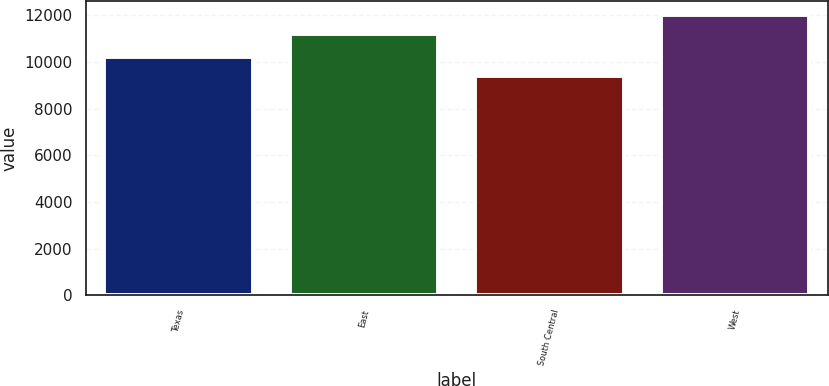Convert chart to OTSL. <chart><loc_0><loc_0><loc_500><loc_500><bar_chart><fcel>Texas<fcel>East<fcel>South Central<fcel>West<nl><fcel>10200<fcel>11200<fcel>9400<fcel>12000<nl></chart> 